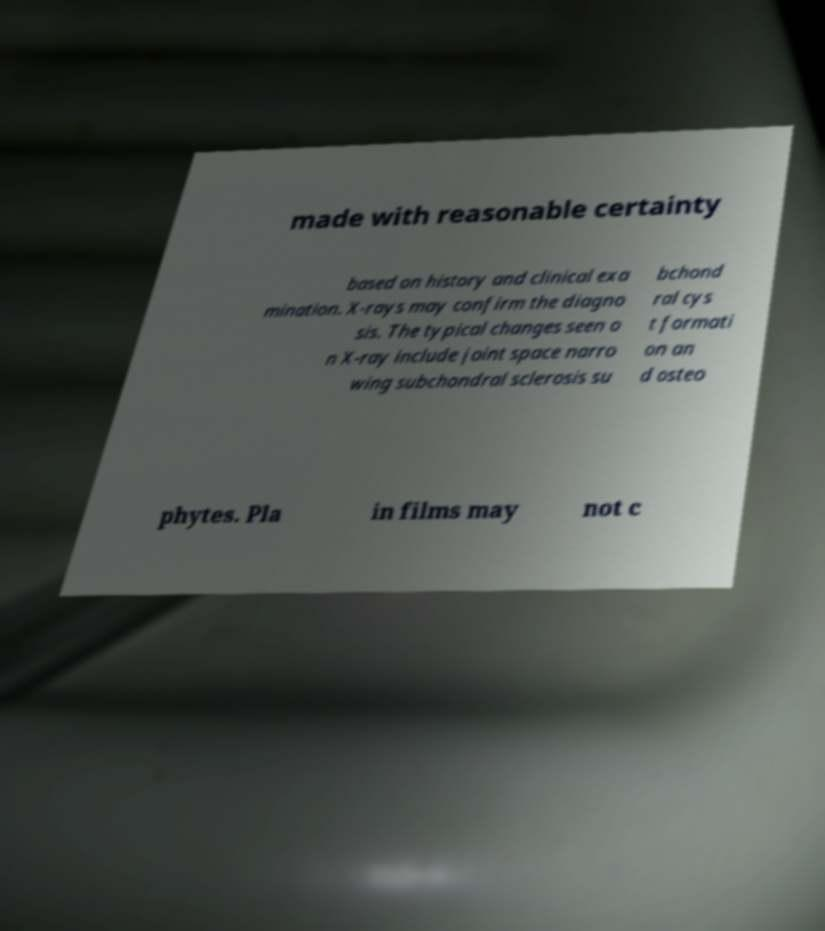Can you read and provide the text displayed in the image?This photo seems to have some interesting text. Can you extract and type it out for me? made with reasonable certainty based on history and clinical exa mination. X-rays may confirm the diagno sis. The typical changes seen o n X-ray include joint space narro wing subchondral sclerosis su bchond ral cys t formati on an d osteo phytes. Pla in films may not c 